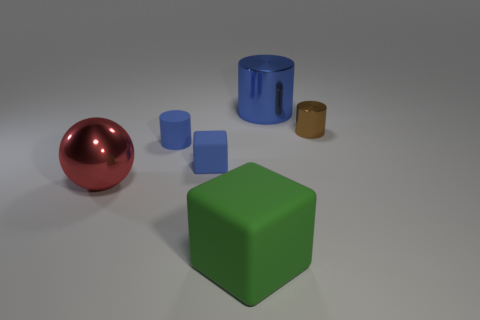There is a metal object that is the same color as the small block; what size is it?
Your answer should be compact. Large. Are there any large red metallic objects?
Your answer should be very brief. Yes. Does the sphere have the same color as the cube behind the large green matte object?
Ensure brevity in your answer.  No. There is a block that is in front of the large metal thing that is to the left of the small blue cylinder that is left of the large blue cylinder; how big is it?
Your response must be concise. Large. What number of large cylinders have the same color as the large block?
Your response must be concise. 0. How many things are large red metallic things or metal objects on the right side of the big red object?
Keep it short and to the point. 3. What is the color of the matte cylinder?
Ensure brevity in your answer.  Blue. What color is the matte block in front of the sphere?
Provide a short and direct response. Green. What number of tiny objects are right of the rubber thing that is in front of the big red metallic ball?
Your response must be concise. 1. Is the size of the red shiny object the same as the blue metal thing behind the tiny rubber cylinder?
Your answer should be compact. Yes. 